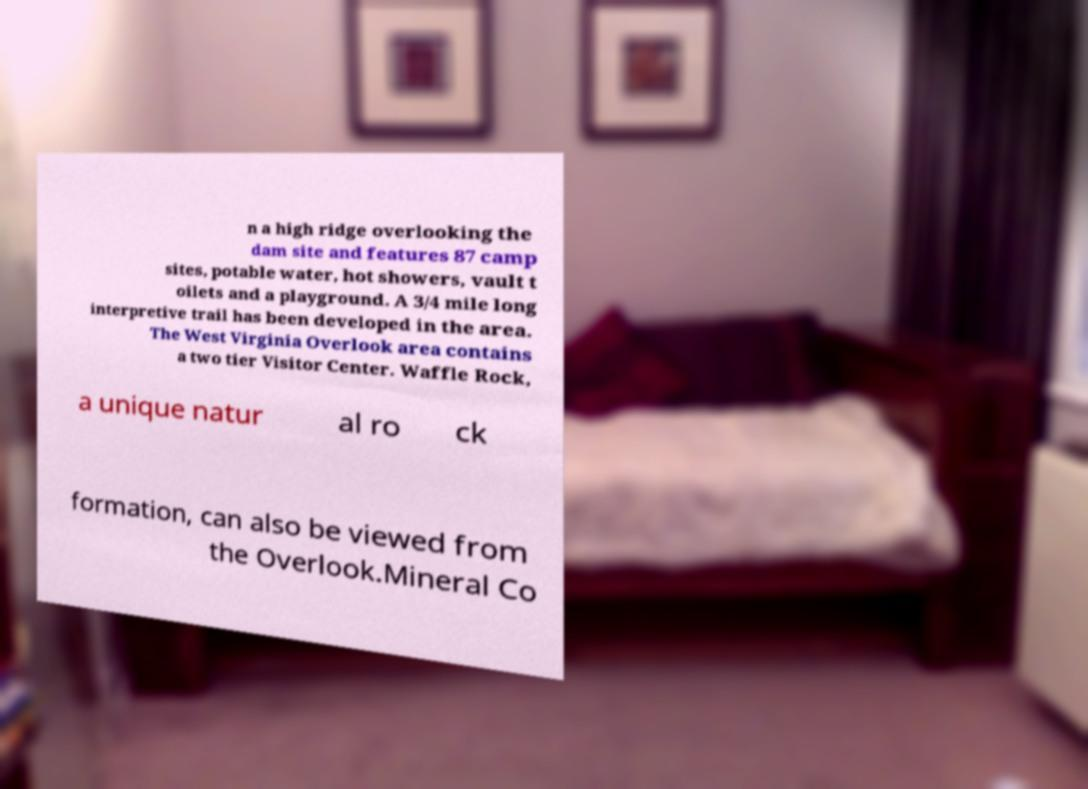What messages or text are displayed in this image? I need them in a readable, typed format. n a high ridge overlooking the dam site and features 87 camp sites, potable water, hot showers, vault t oilets and a playground. A 3/4 mile long interpretive trail has been developed in the area. The West Virginia Overlook area contains a two tier Visitor Center. Waffle Rock, a unique natur al ro ck formation, can also be viewed from the Overlook.Mineral Co 